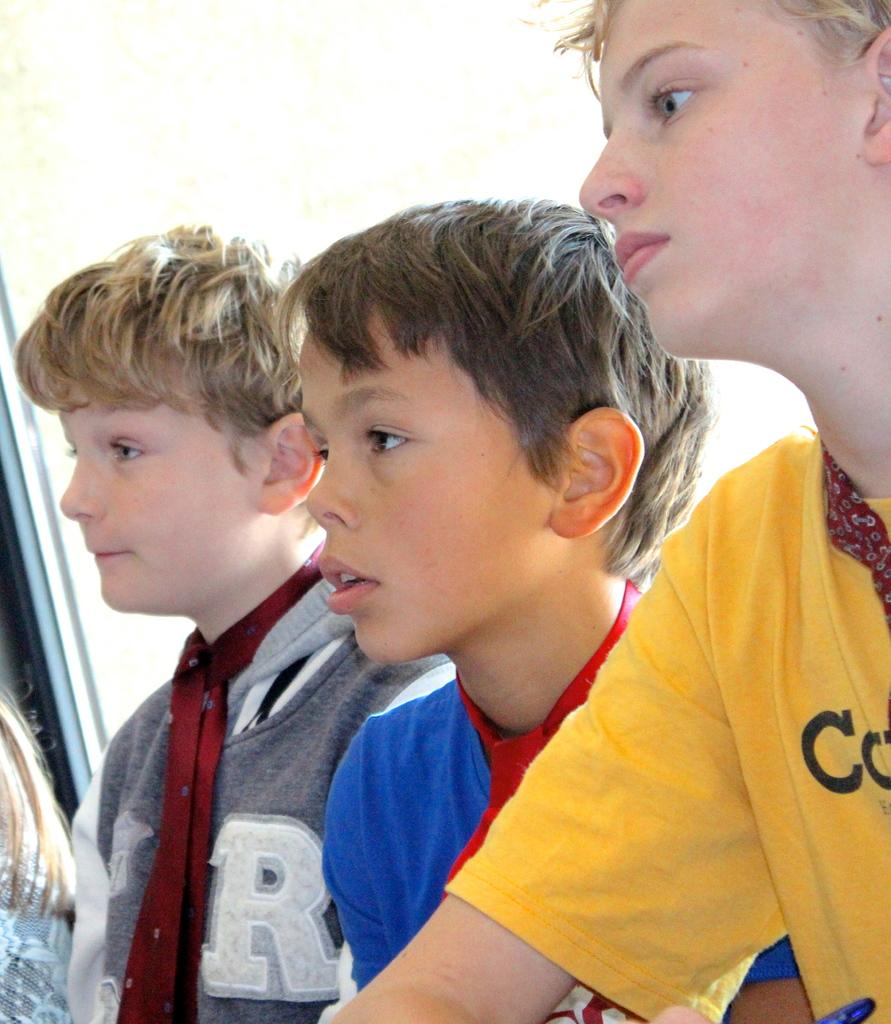What can be observed about the people in the image? There are people with different color dresses in the image. What is the color of the background in the image? The background of the image is white. What type of wall can be seen in the image? There is no wall present in the image. How many thumbs are visible in the image? There is no information about thumbs in the provided facts, so we cannot determine the number of thumbs visible in the image. 